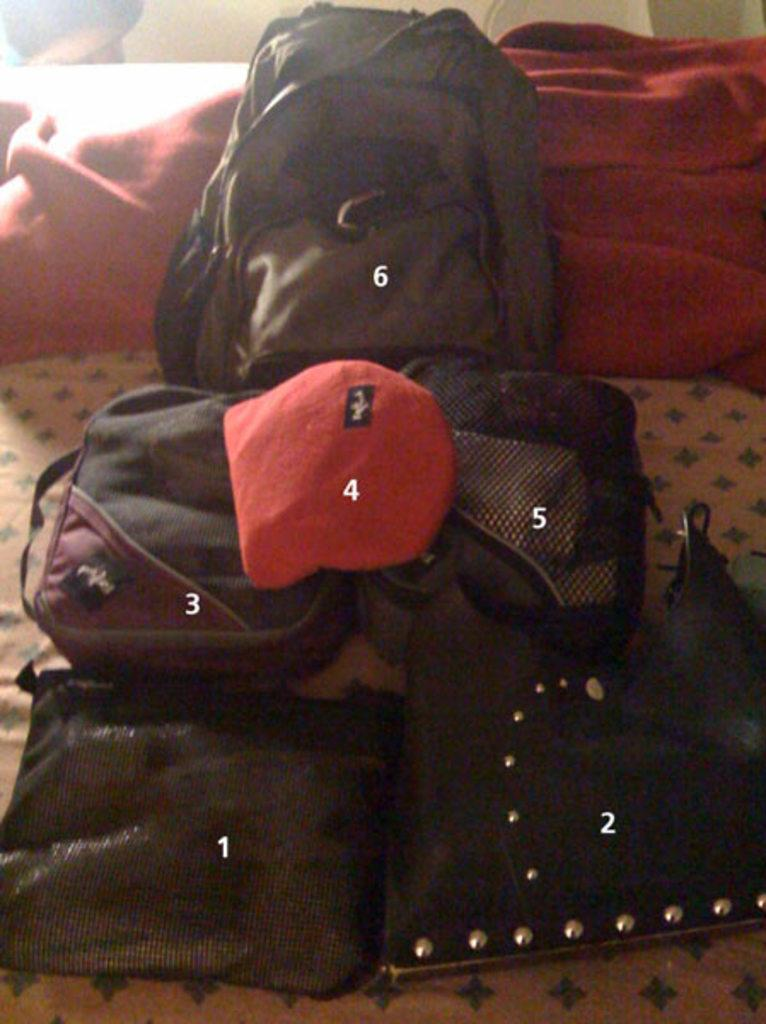How many bags are visible in the image? There are six bags in the image. What distinguishes each bag from the others? Each bag has a number assigned to it. What type of produce is being sold in the image? There is no produce visible in the image; it only shows six bags with numbers assigned to them. 